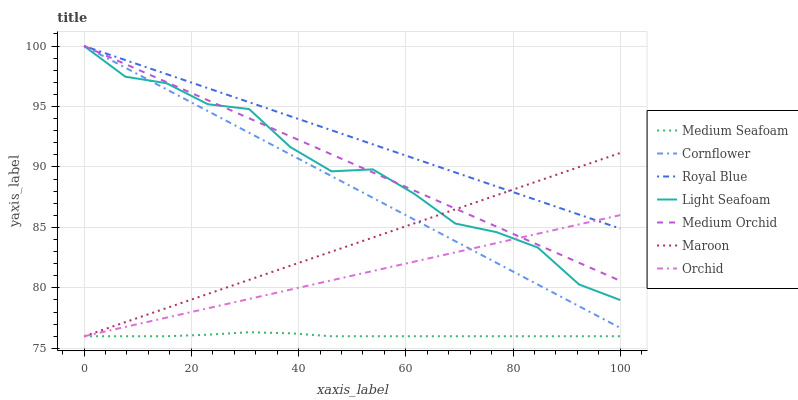Does Medium Seafoam have the minimum area under the curve?
Answer yes or no. Yes. Does Royal Blue have the maximum area under the curve?
Answer yes or no. Yes. Does Medium Orchid have the minimum area under the curve?
Answer yes or no. No. Does Medium Orchid have the maximum area under the curve?
Answer yes or no. No. Is Maroon the smoothest?
Answer yes or no. Yes. Is Light Seafoam the roughest?
Answer yes or no. Yes. Is Medium Orchid the smoothest?
Answer yes or no. No. Is Medium Orchid the roughest?
Answer yes or no. No. Does Maroon have the lowest value?
Answer yes or no. Yes. Does Medium Orchid have the lowest value?
Answer yes or no. No. Does Light Seafoam have the highest value?
Answer yes or no. Yes. Does Maroon have the highest value?
Answer yes or no. No. Is Medium Seafoam less than Cornflower?
Answer yes or no. Yes. Is Cornflower greater than Medium Seafoam?
Answer yes or no. Yes. Does Cornflower intersect Light Seafoam?
Answer yes or no. Yes. Is Cornflower less than Light Seafoam?
Answer yes or no. No. Is Cornflower greater than Light Seafoam?
Answer yes or no. No. Does Medium Seafoam intersect Cornflower?
Answer yes or no. No. 